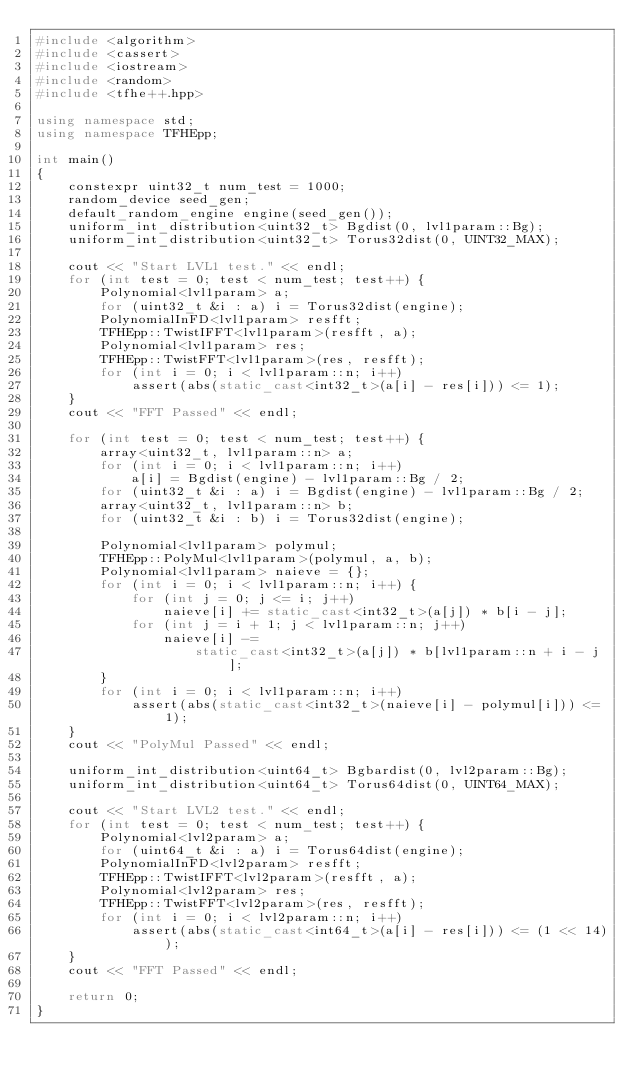Convert code to text. <code><loc_0><loc_0><loc_500><loc_500><_C++_>#include <algorithm>
#include <cassert>
#include <iostream>
#include <random>
#include <tfhe++.hpp>

using namespace std;
using namespace TFHEpp;

int main()
{
    constexpr uint32_t num_test = 1000;
    random_device seed_gen;
    default_random_engine engine(seed_gen());
    uniform_int_distribution<uint32_t> Bgdist(0, lvl1param::Bg);
    uniform_int_distribution<uint32_t> Torus32dist(0, UINT32_MAX);

    cout << "Start LVL1 test." << endl;
    for (int test = 0; test < num_test; test++) {
        Polynomial<lvl1param> a;
        for (uint32_t &i : a) i = Torus32dist(engine);
        PolynomialInFD<lvl1param> resfft;
        TFHEpp::TwistIFFT<lvl1param>(resfft, a);
        Polynomial<lvl1param> res;
        TFHEpp::TwistFFT<lvl1param>(res, resfft);
        for (int i = 0; i < lvl1param::n; i++)
            assert(abs(static_cast<int32_t>(a[i] - res[i])) <= 1);
    }
    cout << "FFT Passed" << endl;

    for (int test = 0; test < num_test; test++) {
        array<uint32_t, lvl1param::n> a;
        for (int i = 0; i < lvl1param::n; i++)
            a[i] = Bgdist(engine) - lvl1param::Bg / 2;
        for (uint32_t &i : a) i = Bgdist(engine) - lvl1param::Bg / 2;
        array<uint32_t, lvl1param::n> b;
        for (uint32_t &i : b) i = Torus32dist(engine);

        Polynomial<lvl1param> polymul;
        TFHEpp::PolyMul<lvl1param>(polymul, a, b);
        Polynomial<lvl1param> naieve = {};
        for (int i = 0; i < lvl1param::n; i++) {
            for (int j = 0; j <= i; j++)
                naieve[i] += static_cast<int32_t>(a[j]) * b[i - j];
            for (int j = i + 1; j < lvl1param::n; j++)
                naieve[i] -=
                    static_cast<int32_t>(a[j]) * b[lvl1param::n + i - j];
        }
        for (int i = 0; i < lvl1param::n; i++)
            assert(abs(static_cast<int32_t>(naieve[i] - polymul[i])) <= 1);
    }
    cout << "PolyMul Passed" << endl;

    uniform_int_distribution<uint64_t> Bgbardist(0, lvl2param::Bg);
    uniform_int_distribution<uint64_t> Torus64dist(0, UINT64_MAX);

    cout << "Start LVL2 test." << endl;
    for (int test = 0; test < num_test; test++) {
        Polynomial<lvl2param> a;
        for (uint64_t &i : a) i = Torus64dist(engine);
        PolynomialInFD<lvl2param> resfft;
        TFHEpp::TwistIFFT<lvl2param>(resfft, a);
        Polynomial<lvl2param> res;
        TFHEpp::TwistFFT<lvl2param>(res, resfft);
        for (int i = 0; i < lvl2param::n; i++)
            assert(abs(static_cast<int64_t>(a[i] - res[i])) <= (1 << 14));
    }
    cout << "FFT Passed" << endl;

    return 0;
}</code> 